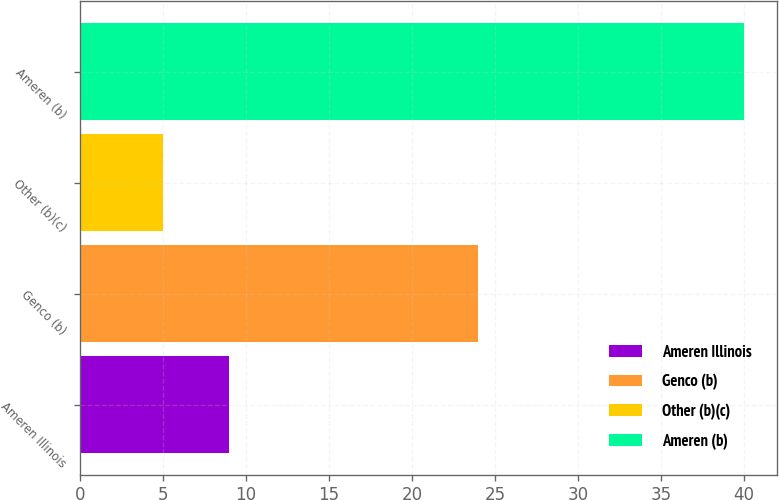<chart> <loc_0><loc_0><loc_500><loc_500><bar_chart><fcel>Ameren Illinois<fcel>Genco (b)<fcel>Other (b)(c)<fcel>Ameren (b)<nl><fcel>9<fcel>24<fcel>5<fcel>40<nl></chart> 